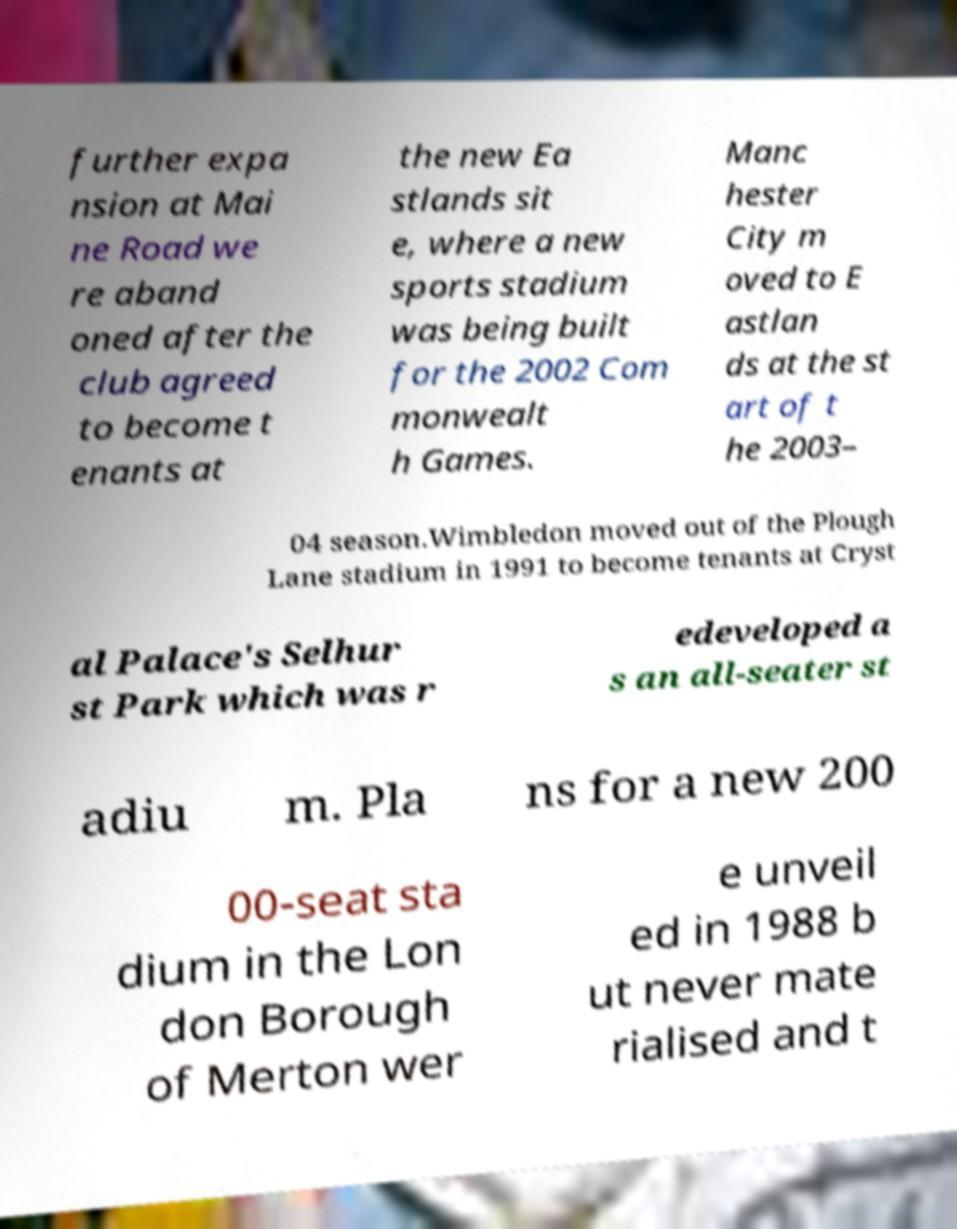I need the written content from this picture converted into text. Can you do that? further expa nsion at Mai ne Road we re aband oned after the club agreed to become t enants at the new Ea stlands sit e, where a new sports stadium was being built for the 2002 Com monwealt h Games. Manc hester City m oved to E astlan ds at the st art of t he 2003– 04 season.Wimbledon moved out of the Plough Lane stadium in 1991 to become tenants at Cryst al Palace's Selhur st Park which was r edeveloped a s an all-seater st adiu m. Pla ns for a new 200 00-seat sta dium in the Lon don Borough of Merton wer e unveil ed in 1988 b ut never mate rialised and t 